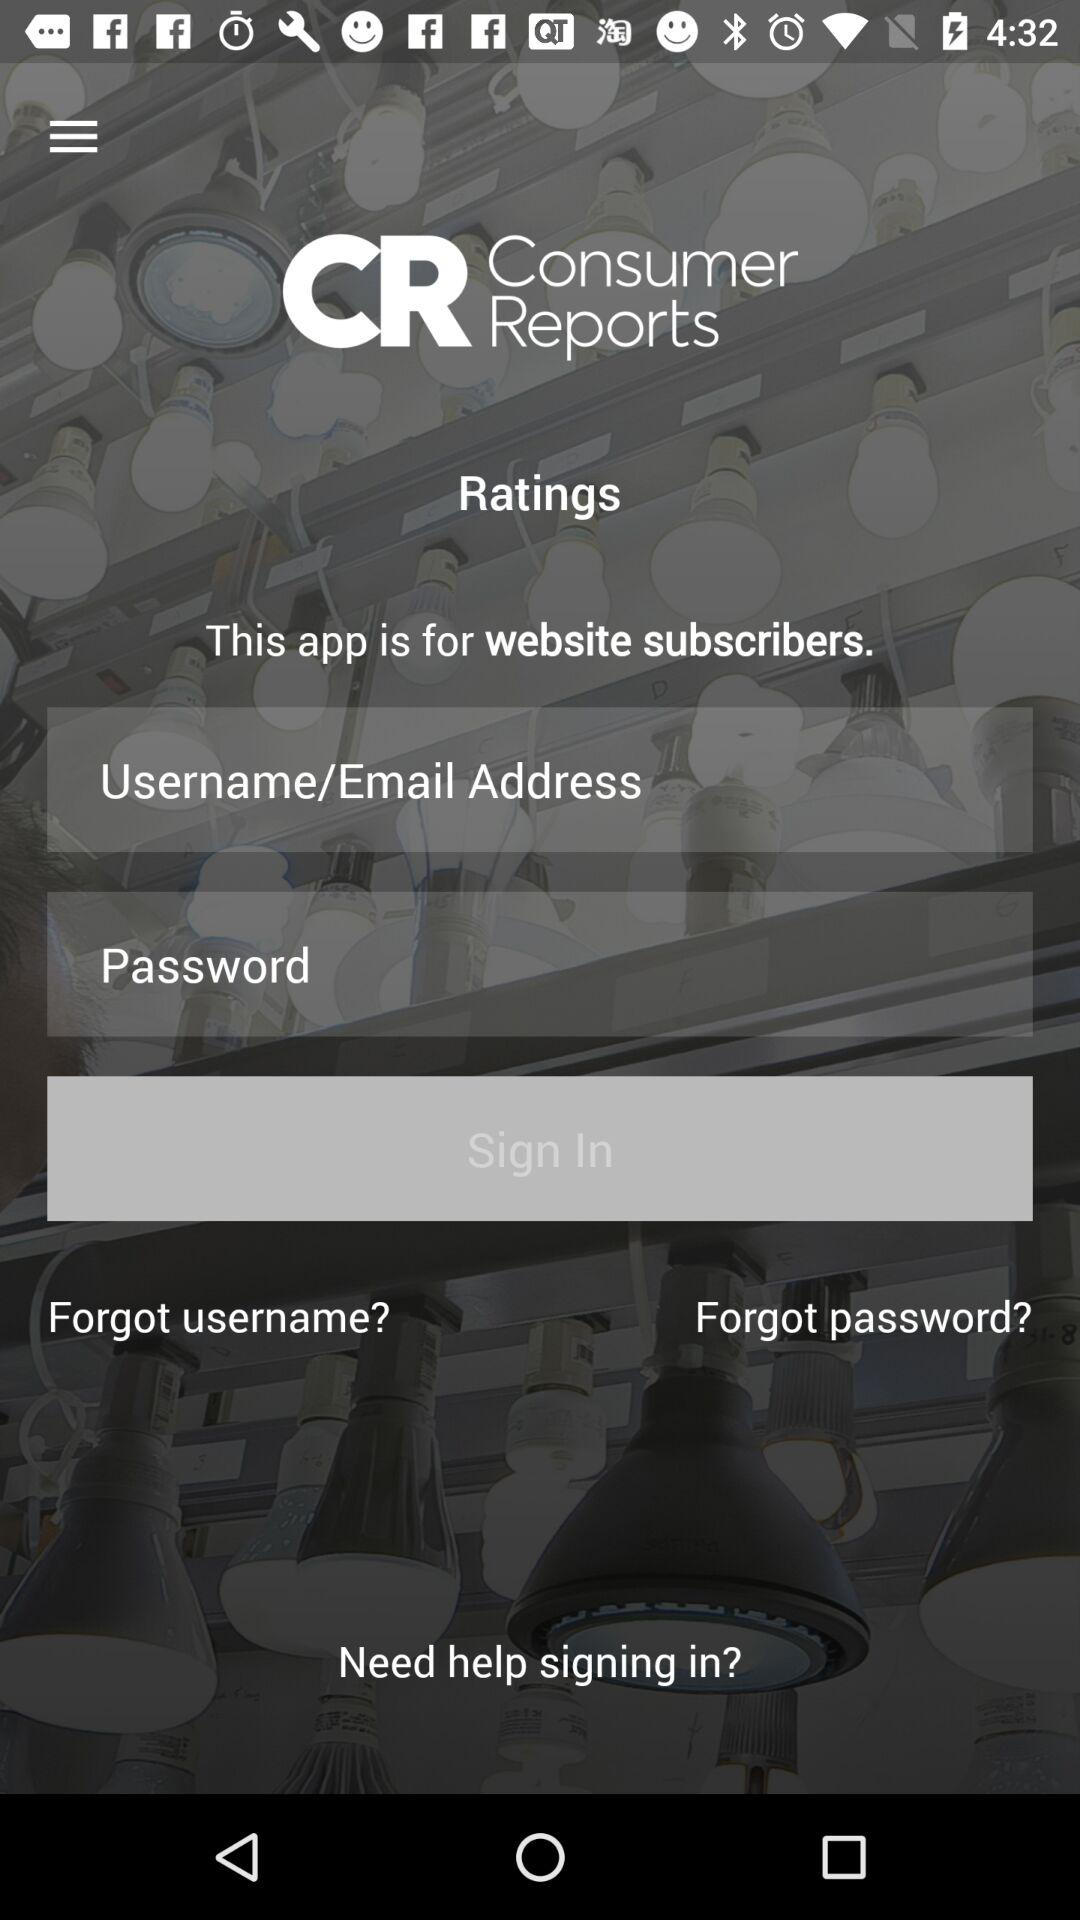What is the name of the application? The name of the application is "Consumer Reports". 